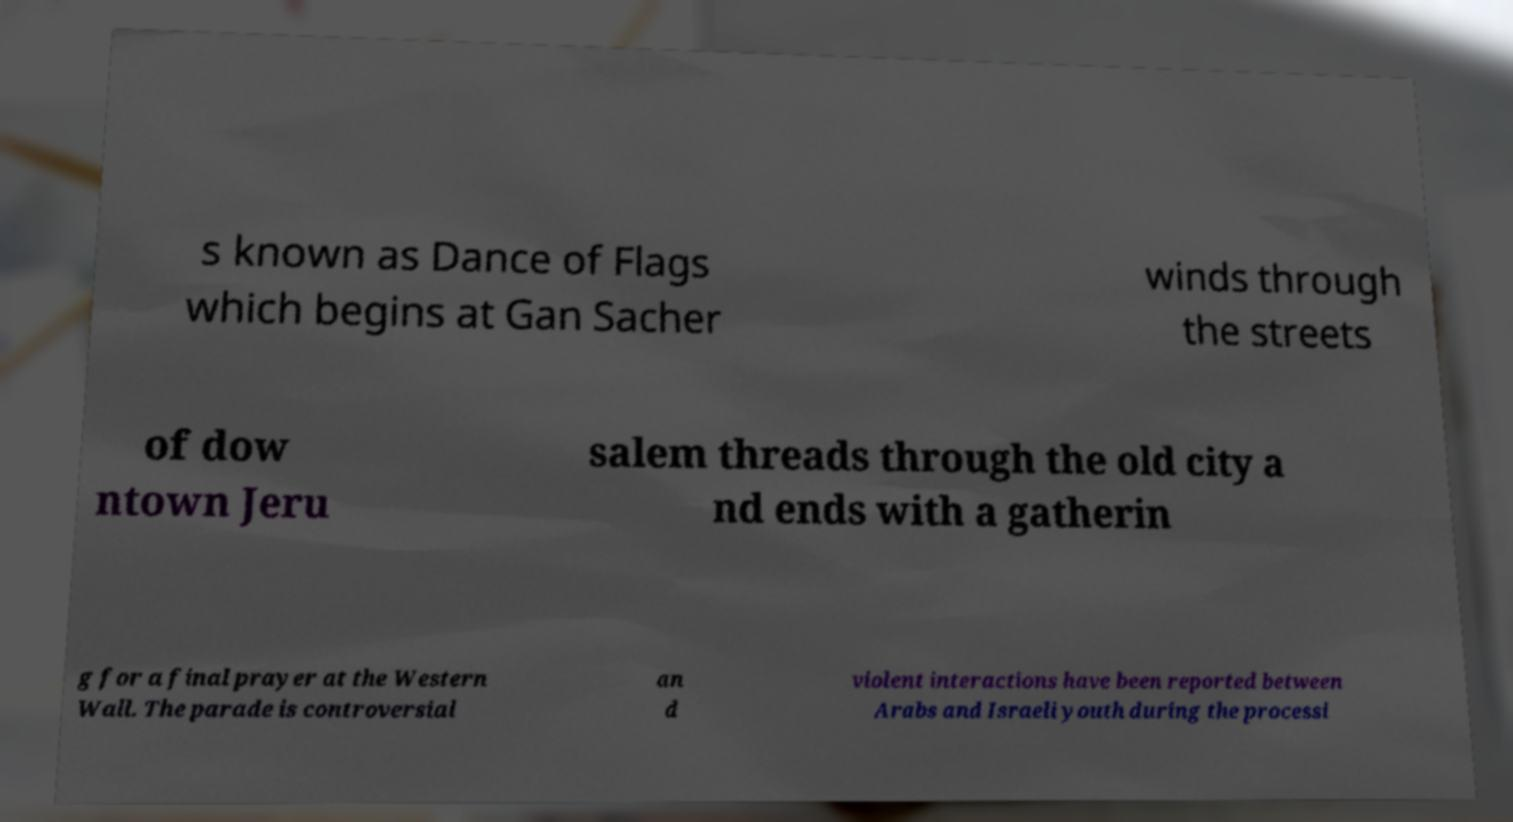Please read and relay the text visible in this image. What does it say? s known as Dance of Flags which begins at Gan Sacher winds through the streets of dow ntown Jeru salem threads through the old city a nd ends with a gatherin g for a final prayer at the Western Wall. The parade is controversial an d violent interactions have been reported between Arabs and Israeli youth during the processi 